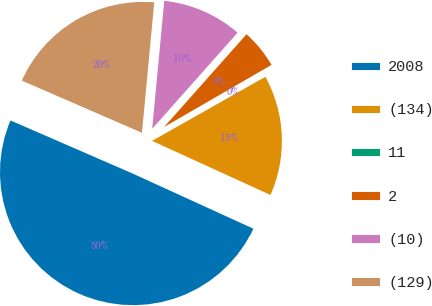Convert chart. <chart><loc_0><loc_0><loc_500><loc_500><pie_chart><fcel>2008<fcel>(134)<fcel>11<fcel>2<fcel>(10)<fcel>(129)<nl><fcel>49.7%<fcel>15.01%<fcel>0.15%<fcel>5.1%<fcel>10.06%<fcel>19.97%<nl></chart> 